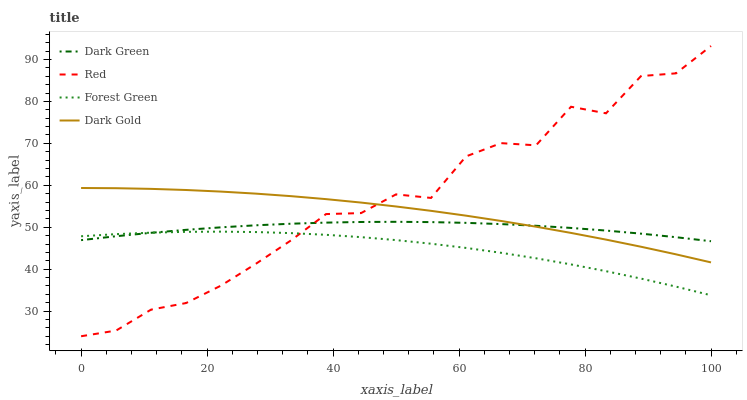Does Forest Green have the minimum area under the curve?
Answer yes or no. Yes. Does Red have the maximum area under the curve?
Answer yes or no. Yes. Does Dark Gold have the minimum area under the curve?
Answer yes or no. No. Does Dark Gold have the maximum area under the curve?
Answer yes or no. No. Is Dark Gold the smoothest?
Answer yes or no. Yes. Is Red the roughest?
Answer yes or no. Yes. Is Red the smoothest?
Answer yes or no. No. Is Dark Gold the roughest?
Answer yes or no. No. Does Red have the lowest value?
Answer yes or no. Yes. Does Dark Gold have the lowest value?
Answer yes or no. No. Does Red have the highest value?
Answer yes or no. Yes. Does Dark Gold have the highest value?
Answer yes or no. No. Is Forest Green less than Dark Gold?
Answer yes or no. Yes. Is Dark Gold greater than Forest Green?
Answer yes or no. Yes. Does Red intersect Dark Green?
Answer yes or no. Yes. Is Red less than Dark Green?
Answer yes or no. No. Is Red greater than Dark Green?
Answer yes or no. No. Does Forest Green intersect Dark Gold?
Answer yes or no. No. 